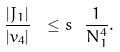Convert formula to latex. <formula><loc_0><loc_0><loc_500><loc_500>\frac { | J _ { 1 } | } { | v _ { 4 } | } \ \leq s \ \frac { 1 } { N _ { 1 } ^ { 4 } } .</formula> 